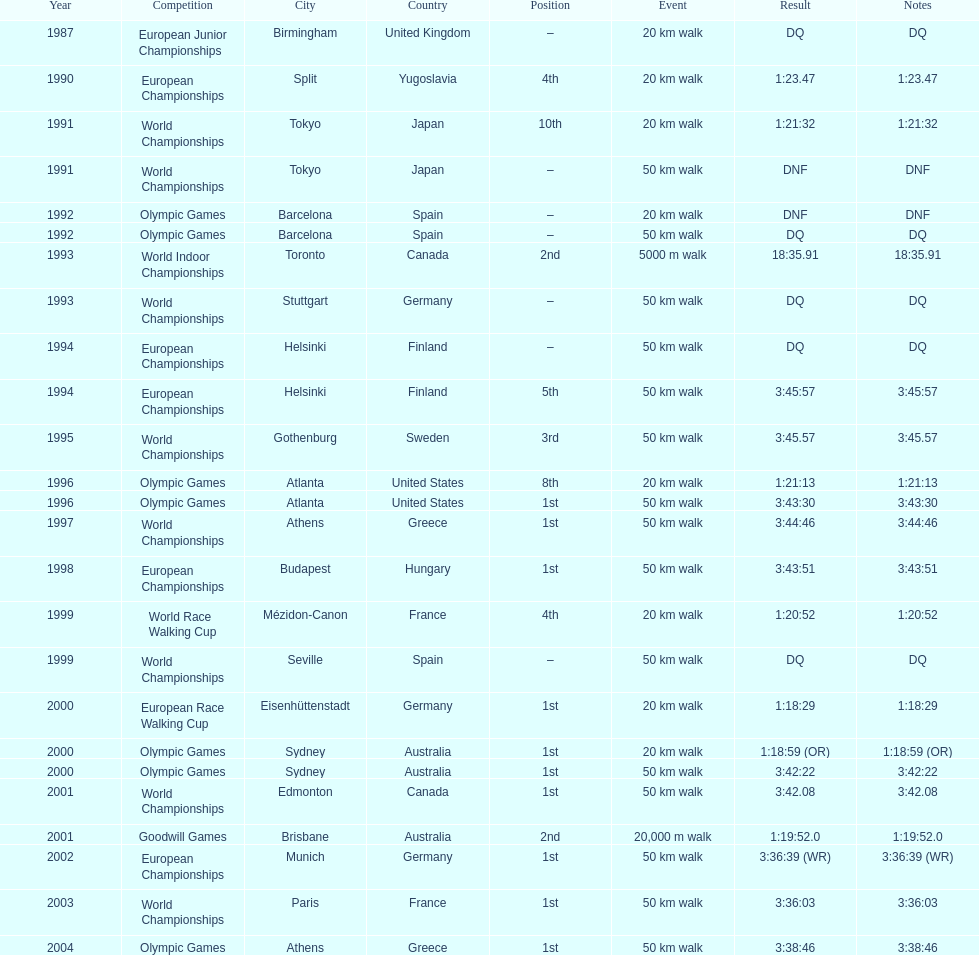Which venue is listed the most? Athens, Greece. 